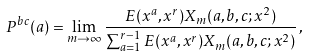Convert formula to latex. <formula><loc_0><loc_0><loc_500><loc_500>P ^ { b c } ( a ) = \lim _ { m \to \infty } \frac { E ( x ^ { a } , x ^ { r } ) X _ { m } ( a , b , c ; x ^ { 2 } ) } { \sum _ { a = 1 } ^ { r - 1 } E ( x ^ { a } , x ^ { r } ) X _ { m } ( a , b , c ; x ^ { 2 } ) } \, ,</formula> 